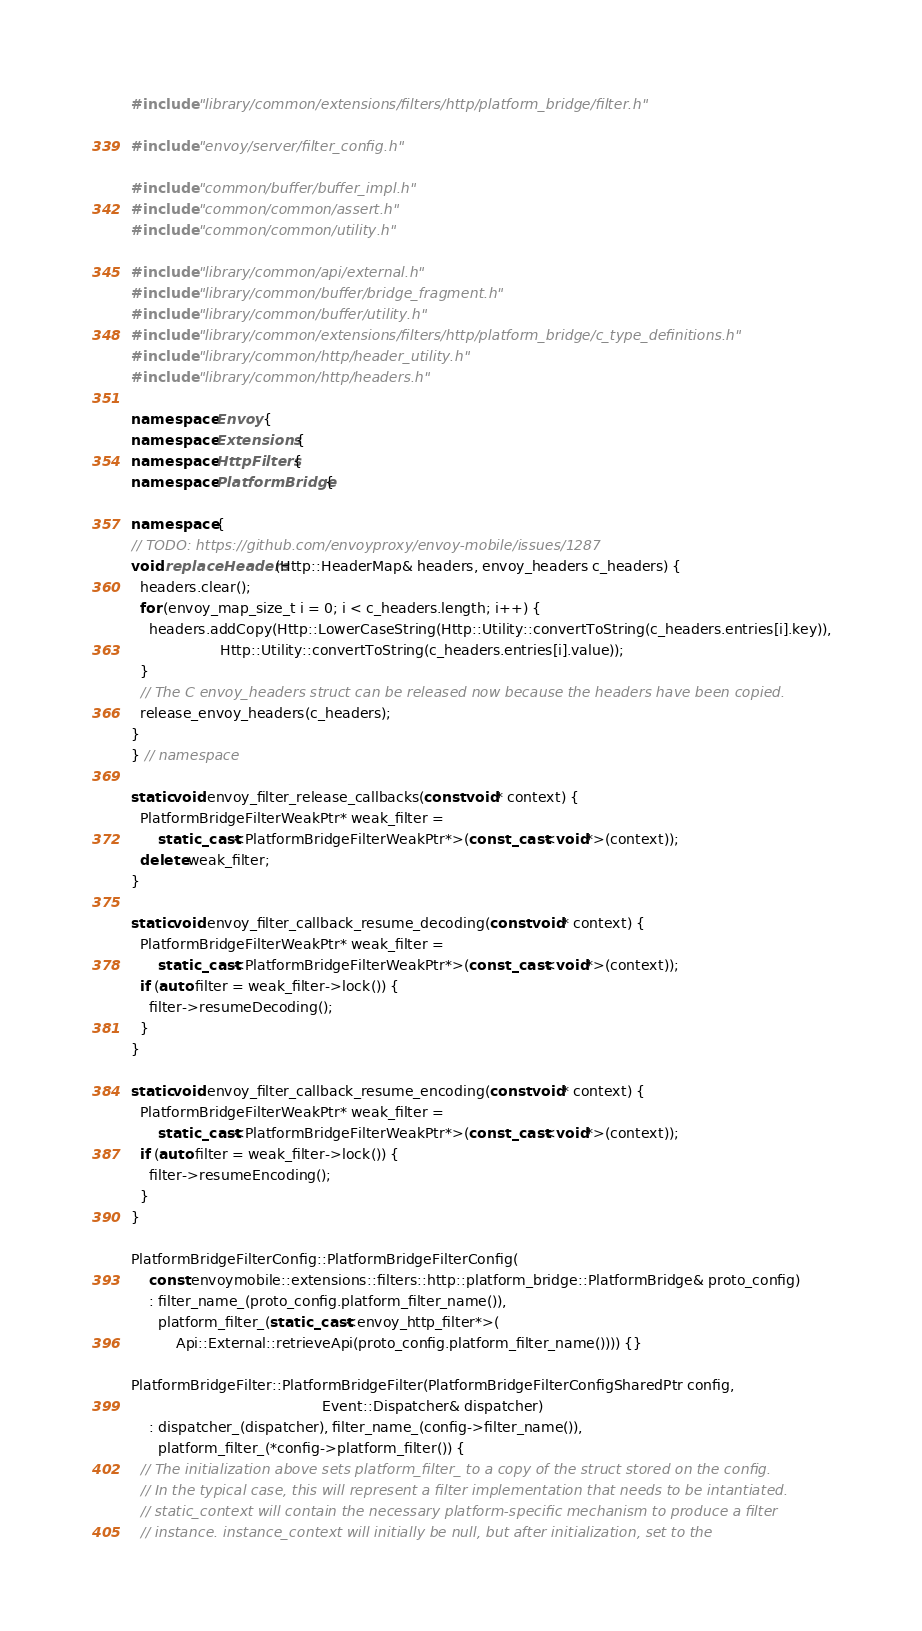<code> <loc_0><loc_0><loc_500><loc_500><_C++_>#include "library/common/extensions/filters/http/platform_bridge/filter.h"

#include "envoy/server/filter_config.h"

#include "common/buffer/buffer_impl.h"
#include "common/common/assert.h"
#include "common/common/utility.h"

#include "library/common/api/external.h"
#include "library/common/buffer/bridge_fragment.h"
#include "library/common/buffer/utility.h"
#include "library/common/extensions/filters/http/platform_bridge/c_type_definitions.h"
#include "library/common/http/header_utility.h"
#include "library/common/http/headers.h"

namespace Envoy {
namespace Extensions {
namespace HttpFilters {
namespace PlatformBridge {

namespace {
// TODO: https://github.com/envoyproxy/envoy-mobile/issues/1287
void replaceHeaders(Http::HeaderMap& headers, envoy_headers c_headers) {
  headers.clear();
  for (envoy_map_size_t i = 0; i < c_headers.length; i++) {
    headers.addCopy(Http::LowerCaseString(Http::Utility::convertToString(c_headers.entries[i].key)),
                    Http::Utility::convertToString(c_headers.entries[i].value));
  }
  // The C envoy_headers struct can be released now because the headers have been copied.
  release_envoy_headers(c_headers);
}
} // namespace

static void envoy_filter_release_callbacks(const void* context) {
  PlatformBridgeFilterWeakPtr* weak_filter =
      static_cast<PlatformBridgeFilterWeakPtr*>(const_cast<void*>(context));
  delete weak_filter;
}

static void envoy_filter_callback_resume_decoding(const void* context) {
  PlatformBridgeFilterWeakPtr* weak_filter =
      static_cast<PlatformBridgeFilterWeakPtr*>(const_cast<void*>(context));
  if (auto filter = weak_filter->lock()) {
    filter->resumeDecoding();
  }
}

static void envoy_filter_callback_resume_encoding(const void* context) {
  PlatformBridgeFilterWeakPtr* weak_filter =
      static_cast<PlatformBridgeFilterWeakPtr*>(const_cast<void*>(context));
  if (auto filter = weak_filter->lock()) {
    filter->resumeEncoding();
  }
}

PlatformBridgeFilterConfig::PlatformBridgeFilterConfig(
    const envoymobile::extensions::filters::http::platform_bridge::PlatformBridge& proto_config)
    : filter_name_(proto_config.platform_filter_name()),
      platform_filter_(static_cast<envoy_http_filter*>(
          Api::External::retrieveApi(proto_config.platform_filter_name()))) {}

PlatformBridgeFilter::PlatformBridgeFilter(PlatformBridgeFilterConfigSharedPtr config,
                                           Event::Dispatcher& dispatcher)
    : dispatcher_(dispatcher), filter_name_(config->filter_name()),
      platform_filter_(*config->platform_filter()) {
  // The initialization above sets platform_filter_ to a copy of the struct stored on the config.
  // In the typical case, this will represent a filter implementation that needs to be intantiated.
  // static_context will contain the necessary platform-specific mechanism to produce a filter
  // instance. instance_context will initially be null, but after initialization, set to the</code> 